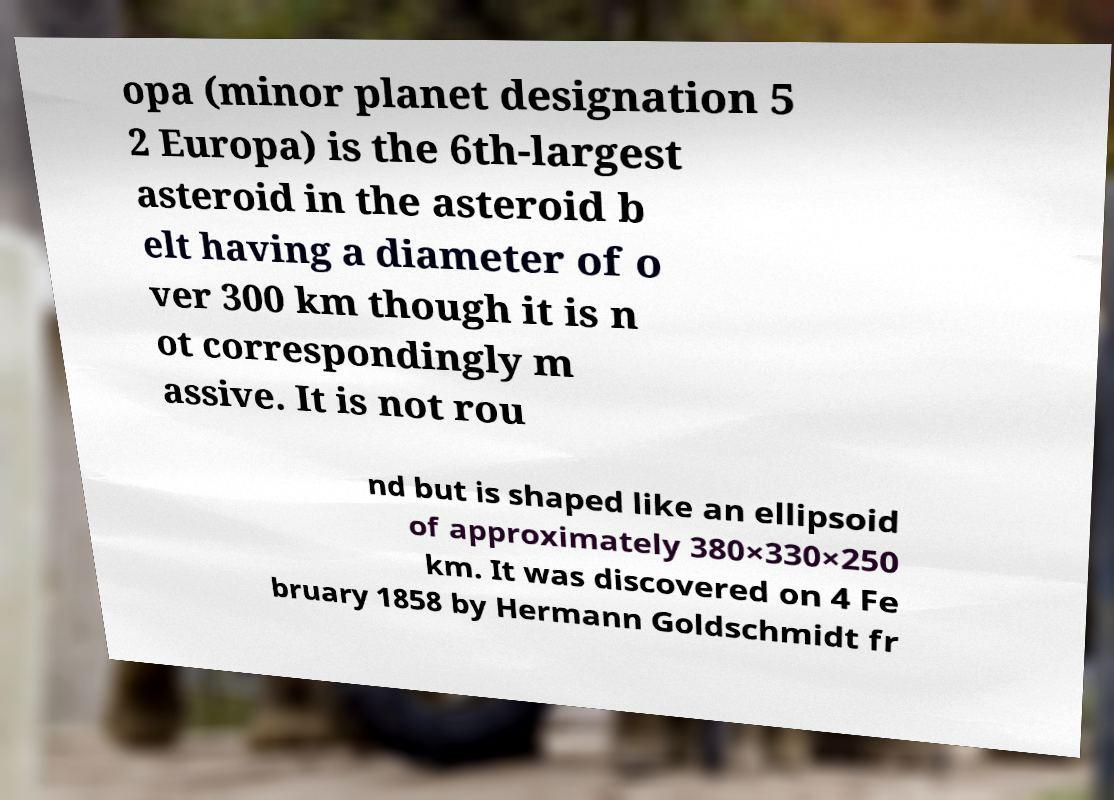There's text embedded in this image that I need extracted. Can you transcribe it verbatim? opa (minor planet designation 5 2 Europa) is the 6th-largest asteroid in the asteroid b elt having a diameter of o ver 300 km though it is n ot correspondingly m assive. It is not rou nd but is shaped like an ellipsoid of approximately 380×330×250 km. It was discovered on 4 Fe bruary 1858 by Hermann Goldschmidt fr 